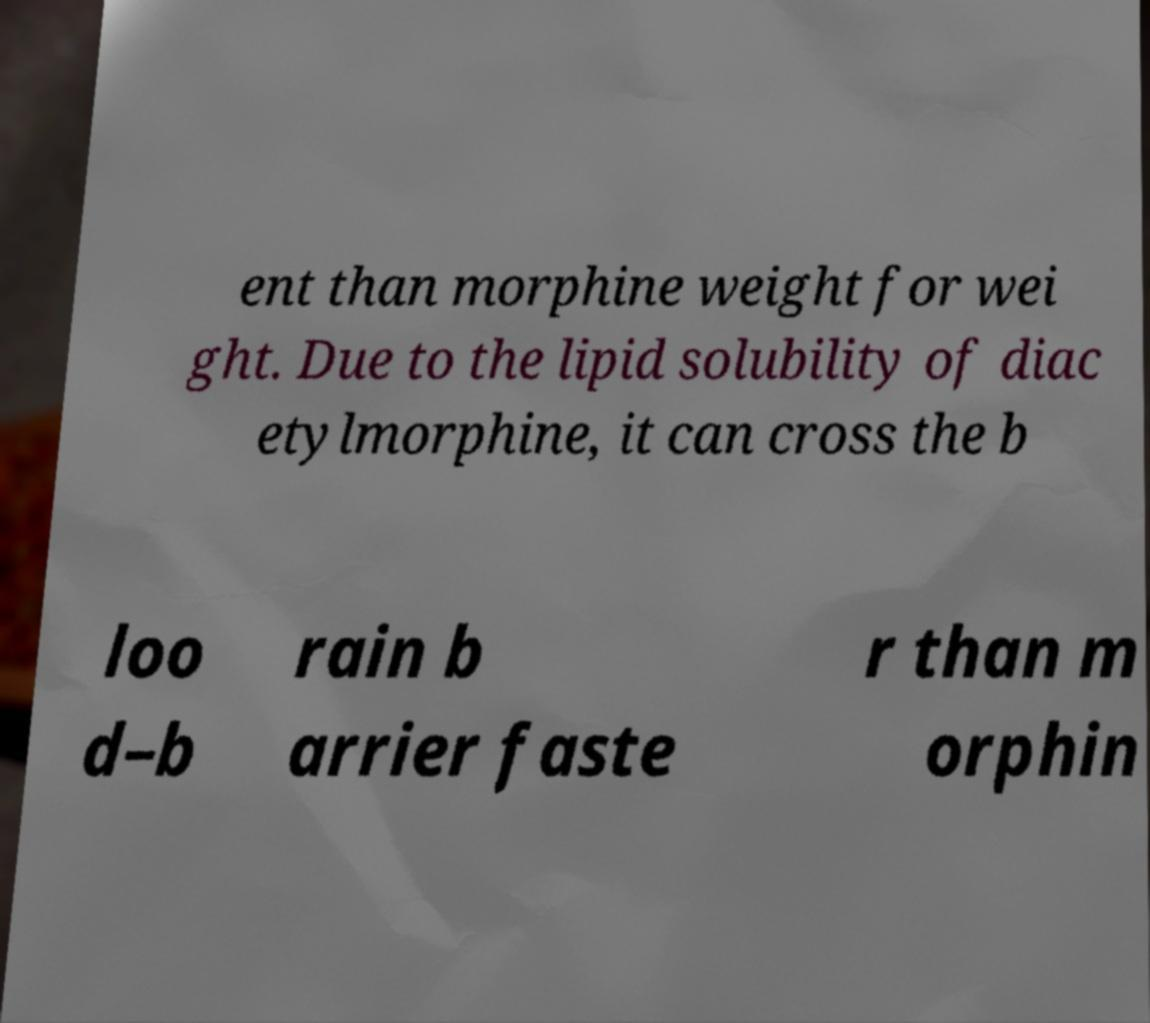Please identify and transcribe the text found in this image. ent than morphine weight for wei ght. Due to the lipid solubility of diac etylmorphine, it can cross the b loo d–b rain b arrier faste r than m orphin 